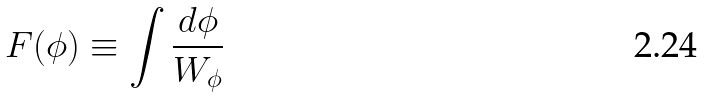<formula> <loc_0><loc_0><loc_500><loc_500>F ( \phi ) \equiv \int \frac { d \phi } { W _ { \phi } }</formula> 